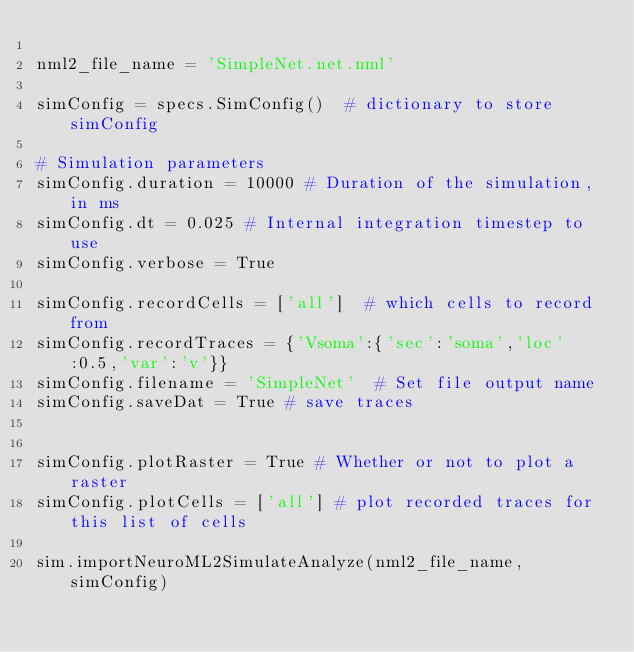Convert code to text. <code><loc_0><loc_0><loc_500><loc_500><_Python_>
nml2_file_name = 'SimpleNet.net.nml'

simConfig = specs.SimConfig()  # dictionary to store simConfig

# Simulation parameters
simConfig.duration = 10000 # Duration of the simulation, in ms
simConfig.dt = 0.025 # Internal integration timestep to use
simConfig.verbose = True

simConfig.recordCells = ['all']  # which cells to record from
simConfig.recordTraces = {'Vsoma':{'sec':'soma','loc':0.5,'var':'v'}}
simConfig.filename = 'SimpleNet'  # Set file output name
simConfig.saveDat = True # save traces


simConfig.plotRaster = True # Whether or not to plot a raster
simConfig.plotCells = ['all'] # plot recorded traces for this list of cells

sim.importNeuroML2SimulateAnalyze(nml2_file_name,simConfig)
</code> 